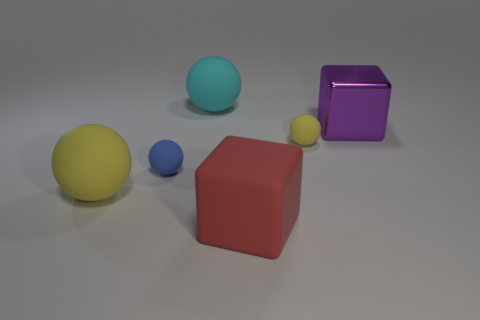Do the large object that is behind the large metallic thing and the big red object have the same material?
Provide a short and direct response. Yes. Is the number of large purple blocks to the right of the purple cube the same as the number of large cyan spheres in front of the cyan rubber object?
Keep it short and to the point. Yes. What is the size of the yellow matte ball that is on the right side of the cube to the left of the purple object?
Your answer should be very brief. Small. There is a large thing that is in front of the small blue rubber thing and behind the red matte cube; what is it made of?
Provide a short and direct response. Rubber. What number of other objects are the same size as the red rubber object?
Offer a terse response. 3. What color is the metallic thing?
Provide a succinct answer. Purple. Does the large ball that is in front of the cyan rubber ball have the same color as the large block that is on the left side of the big purple block?
Make the answer very short. No. What is the size of the cyan rubber ball?
Provide a short and direct response. Large. There is a rubber object that is behind the big metal cube; how big is it?
Make the answer very short. Large. The big object that is to the left of the large red thing and behind the small blue matte thing has what shape?
Ensure brevity in your answer.  Sphere. 